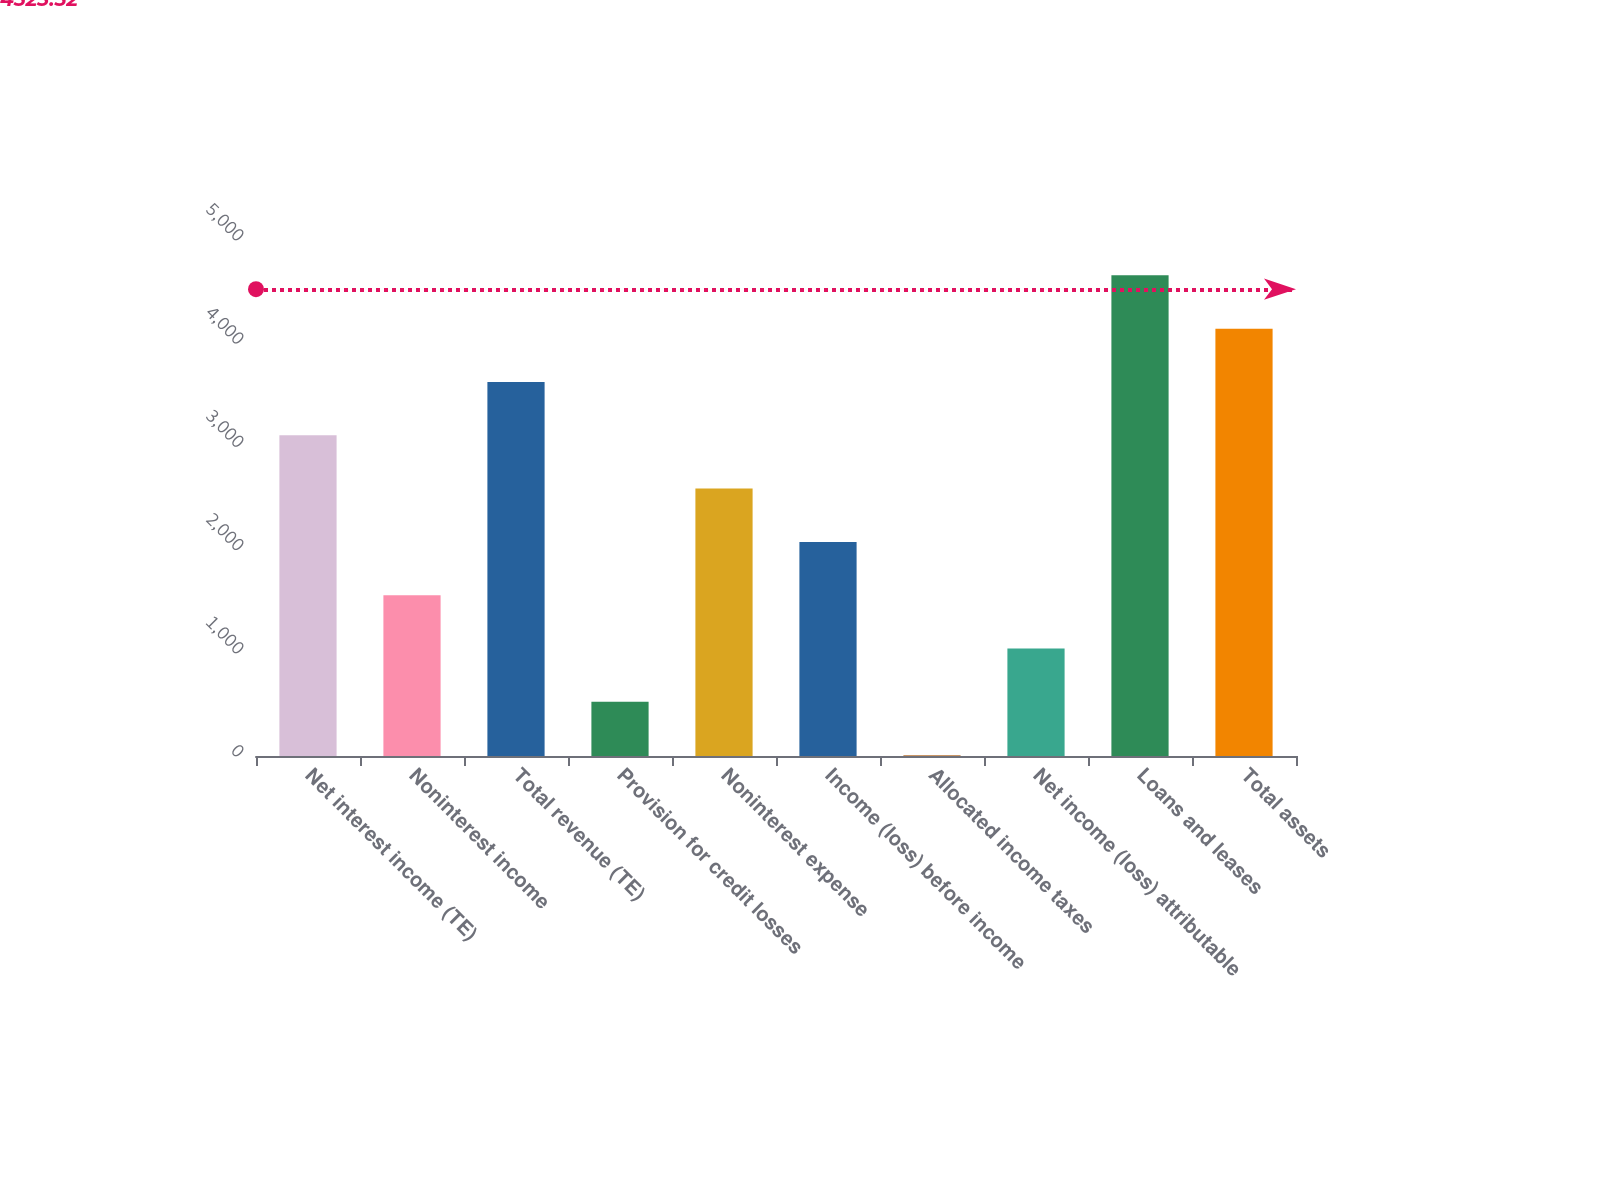Convert chart to OTSL. <chart><loc_0><loc_0><loc_500><loc_500><bar_chart><fcel>Net interest income (TE)<fcel>Noninterest income<fcel>Total revenue (TE)<fcel>Provision for credit losses<fcel>Noninterest expense<fcel>Income (loss) before income<fcel>Allocated income taxes<fcel>Net income (loss) attributable<fcel>Loans and leases<fcel>Total assets<nl><fcel>3107.6<fcel>1557.8<fcel>3624.2<fcel>524.6<fcel>2591<fcel>2074.4<fcel>8<fcel>1041.2<fcel>4657.4<fcel>4140.8<nl></chart> 